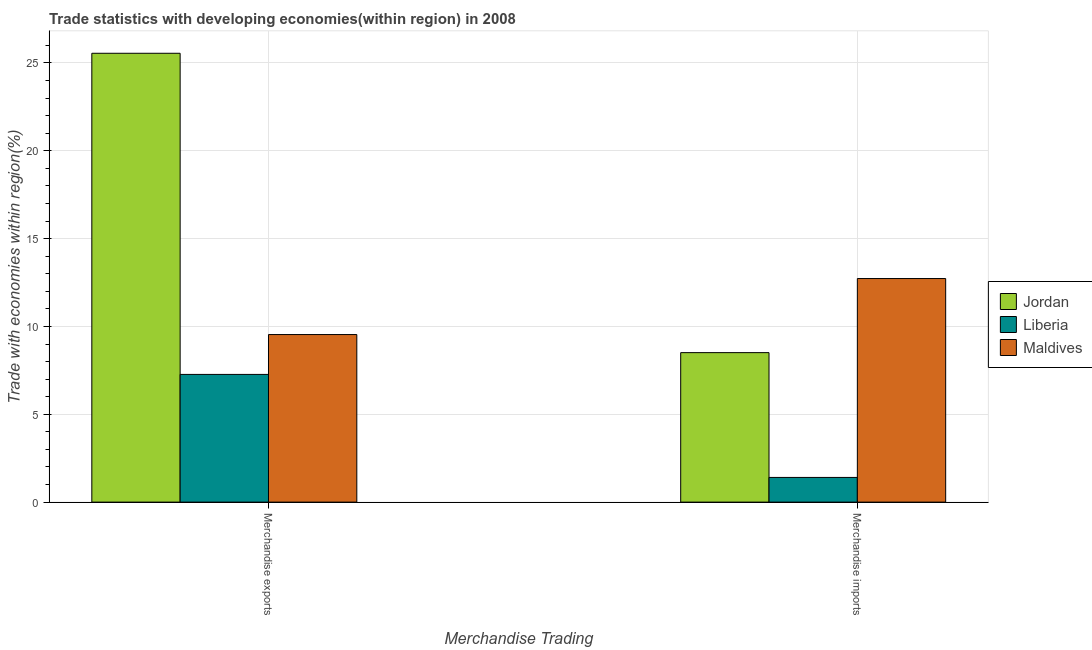How many different coloured bars are there?
Keep it short and to the point. 3. How many groups of bars are there?
Your response must be concise. 2. Are the number of bars on each tick of the X-axis equal?
Keep it short and to the point. Yes. How many bars are there on the 2nd tick from the left?
Give a very brief answer. 3. How many bars are there on the 1st tick from the right?
Give a very brief answer. 3. What is the label of the 1st group of bars from the left?
Your response must be concise. Merchandise exports. What is the merchandise imports in Jordan?
Keep it short and to the point. 8.51. Across all countries, what is the maximum merchandise exports?
Ensure brevity in your answer.  25.55. Across all countries, what is the minimum merchandise imports?
Offer a very short reply. 1.41. In which country was the merchandise imports maximum?
Your response must be concise. Maldives. In which country was the merchandise imports minimum?
Your answer should be compact. Liberia. What is the total merchandise exports in the graph?
Your response must be concise. 42.36. What is the difference between the merchandise imports in Maldives and that in Liberia?
Provide a succinct answer. 11.32. What is the difference between the merchandise imports in Maldives and the merchandise exports in Jordan?
Your answer should be compact. -12.82. What is the average merchandise imports per country?
Provide a succinct answer. 7.55. What is the difference between the merchandise imports and merchandise exports in Maldives?
Offer a terse response. 3.19. What is the ratio of the merchandise exports in Maldives to that in Jordan?
Offer a very short reply. 0.37. In how many countries, is the merchandise imports greater than the average merchandise imports taken over all countries?
Your response must be concise. 2. What does the 1st bar from the left in Merchandise exports represents?
Provide a succinct answer. Jordan. What does the 1st bar from the right in Merchandise exports represents?
Your answer should be very brief. Maldives. Are all the bars in the graph horizontal?
Your answer should be compact. No. What is the difference between two consecutive major ticks on the Y-axis?
Your response must be concise. 5. Does the graph contain grids?
Offer a terse response. Yes. What is the title of the graph?
Your answer should be very brief. Trade statistics with developing economies(within region) in 2008. Does "Iceland" appear as one of the legend labels in the graph?
Your answer should be very brief. No. What is the label or title of the X-axis?
Provide a succinct answer. Merchandise Trading. What is the label or title of the Y-axis?
Give a very brief answer. Trade with economies within region(%). What is the Trade with economies within region(%) in Jordan in Merchandise exports?
Provide a short and direct response. 25.55. What is the Trade with economies within region(%) of Liberia in Merchandise exports?
Offer a terse response. 7.27. What is the Trade with economies within region(%) in Maldives in Merchandise exports?
Your response must be concise. 9.54. What is the Trade with economies within region(%) of Jordan in Merchandise imports?
Keep it short and to the point. 8.51. What is the Trade with economies within region(%) in Liberia in Merchandise imports?
Your response must be concise. 1.41. What is the Trade with economies within region(%) in Maldives in Merchandise imports?
Offer a very short reply. 12.73. Across all Merchandise Trading, what is the maximum Trade with economies within region(%) of Jordan?
Offer a terse response. 25.55. Across all Merchandise Trading, what is the maximum Trade with economies within region(%) in Liberia?
Offer a terse response. 7.27. Across all Merchandise Trading, what is the maximum Trade with economies within region(%) of Maldives?
Ensure brevity in your answer.  12.73. Across all Merchandise Trading, what is the minimum Trade with economies within region(%) in Jordan?
Make the answer very short. 8.51. Across all Merchandise Trading, what is the minimum Trade with economies within region(%) of Liberia?
Offer a terse response. 1.41. Across all Merchandise Trading, what is the minimum Trade with economies within region(%) in Maldives?
Ensure brevity in your answer.  9.54. What is the total Trade with economies within region(%) of Jordan in the graph?
Give a very brief answer. 34.06. What is the total Trade with economies within region(%) of Liberia in the graph?
Give a very brief answer. 8.68. What is the total Trade with economies within region(%) in Maldives in the graph?
Provide a succinct answer. 22.27. What is the difference between the Trade with economies within region(%) in Jordan in Merchandise exports and that in Merchandise imports?
Your response must be concise. 17.04. What is the difference between the Trade with economies within region(%) in Liberia in Merchandise exports and that in Merchandise imports?
Offer a terse response. 5.86. What is the difference between the Trade with economies within region(%) in Maldives in Merchandise exports and that in Merchandise imports?
Ensure brevity in your answer.  -3.19. What is the difference between the Trade with economies within region(%) of Jordan in Merchandise exports and the Trade with economies within region(%) of Liberia in Merchandise imports?
Provide a short and direct response. 24.15. What is the difference between the Trade with economies within region(%) in Jordan in Merchandise exports and the Trade with economies within region(%) in Maldives in Merchandise imports?
Keep it short and to the point. 12.82. What is the difference between the Trade with economies within region(%) in Liberia in Merchandise exports and the Trade with economies within region(%) in Maldives in Merchandise imports?
Keep it short and to the point. -5.46. What is the average Trade with economies within region(%) of Jordan per Merchandise Trading?
Your answer should be compact. 17.03. What is the average Trade with economies within region(%) of Liberia per Merchandise Trading?
Offer a very short reply. 4.34. What is the average Trade with economies within region(%) in Maldives per Merchandise Trading?
Provide a succinct answer. 11.13. What is the difference between the Trade with economies within region(%) of Jordan and Trade with economies within region(%) of Liberia in Merchandise exports?
Offer a very short reply. 18.28. What is the difference between the Trade with economies within region(%) in Jordan and Trade with economies within region(%) in Maldives in Merchandise exports?
Keep it short and to the point. 16.01. What is the difference between the Trade with economies within region(%) in Liberia and Trade with economies within region(%) in Maldives in Merchandise exports?
Provide a short and direct response. -2.27. What is the difference between the Trade with economies within region(%) in Jordan and Trade with economies within region(%) in Liberia in Merchandise imports?
Offer a terse response. 7.11. What is the difference between the Trade with economies within region(%) of Jordan and Trade with economies within region(%) of Maldives in Merchandise imports?
Your answer should be very brief. -4.22. What is the difference between the Trade with economies within region(%) in Liberia and Trade with economies within region(%) in Maldives in Merchandise imports?
Make the answer very short. -11.32. What is the ratio of the Trade with economies within region(%) of Jordan in Merchandise exports to that in Merchandise imports?
Provide a succinct answer. 3. What is the ratio of the Trade with economies within region(%) of Liberia in Merchandise exports to that in Merchandise imports?
Offer a very short reply. 5.17. What is the ratio of the Trade with economies within region(%) of Maldives in Merchandise exports to that in Merchandise imports?
Give a very brief answer. 0.75. What is the difference between the highest and the second highest Trade with economies within region(%) of Jordan?
Provide a succinct answer. 17.04. What is the difference between the highest and the second highest Trade with economies within region(%) in Liberia?
Offer a very short reply. 5.86. What is the difference between the highest and the second highest Trade with economies within region(%) of Maldives?
Provide a short and direct response. 3.19. What is the difference between the highest and the lowest Trade with economies within region(%) of Jordan?
Offer a very short reply. 17.04. What is the difference between the highest and the lowest Trade with economies within region(%) in Liberia?
Offer a terse response. 5.86. What is the difference between the highest and the lowest Trade with economies within region(%) of Maldives?
Provide a succinct answer. 3.19. 